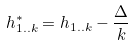Convert formula to latex. <formula><loc_0><loc_0><loc_500><loc_500>h _ { 1 . . k } ^ { * } = h _ { 1 . . k } - \frac { \Delta } { k }</formula> 